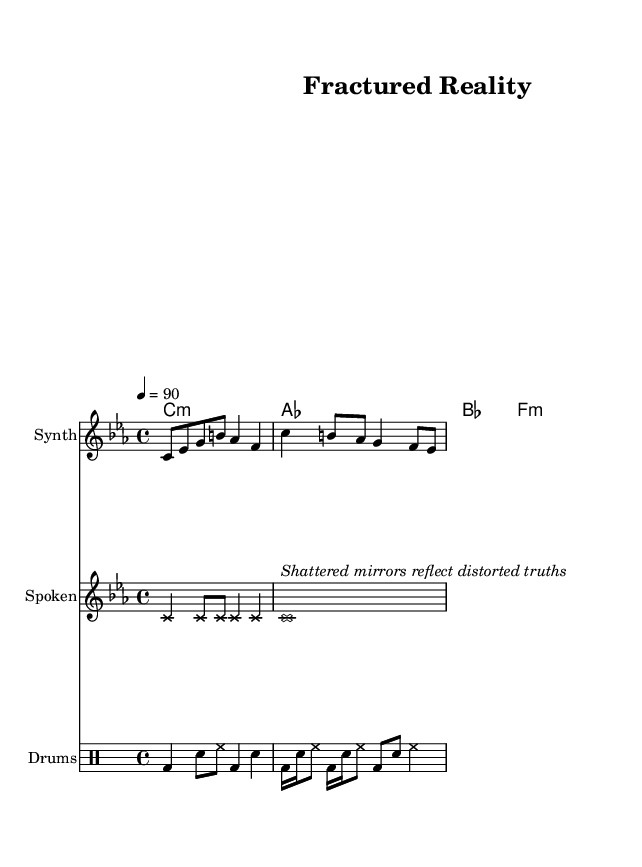What is the key signature of this music? The key signature is C minor, which has three flats (B♭, E♭, A♭). This is indicated at the beginning of the staff.
Answer: C minor What is the time signature of this music? The time signature is 4/4, which is noted at the start of the score. This means there are four beats in each measure.
Answer: 4/4 What is the tempo of the piece? The tempo is marked as 4 = 90, which indicates that there are 90 quarter note beats per minute. This is usually found at the beginning of the score.
Answer: 90 How many bars are in the synth melody? The synth melody is composed of four bars, which can be counted by looking at the number of vertical lines dividing the measures.
Answer: 4 What instrument is used for spoken word? The instrument labeled for spoken word is the spoken staff, characterized by the use of crossing note heads. This is clearly indicated in the score.
Answer: Spoken How does the drum part contribute to the avant-garde style? The drum part features unconventional rhythms and syncopation, using various combinations of bass drum, snare, and hi-hat which are characteristic of avant-garde hip-hop. This fusion creates an experimental sound.
Answer: Unconventional rhythms What is the significance of the line "Shattered mirrors reflect distorted truths"? This line represents a thematic element reflecting concepts of perception and reality, using surreal imagery, a common practice in avant-garde and hip-hop poetry. This contributes depth to the spoken word section of the piece.
Answer: Perception and reality 